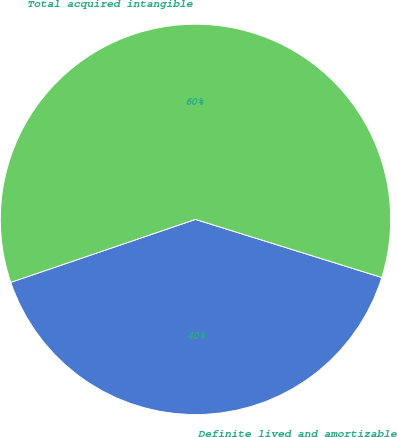<chart> <loc_0><loc_0><loc_500><loc_500><pie_chart><fcel>Definite lived and amortizable<fcel>Total acquired intangible<nl><fcel>39.96%<fcel>60.04%<nl></chart> 